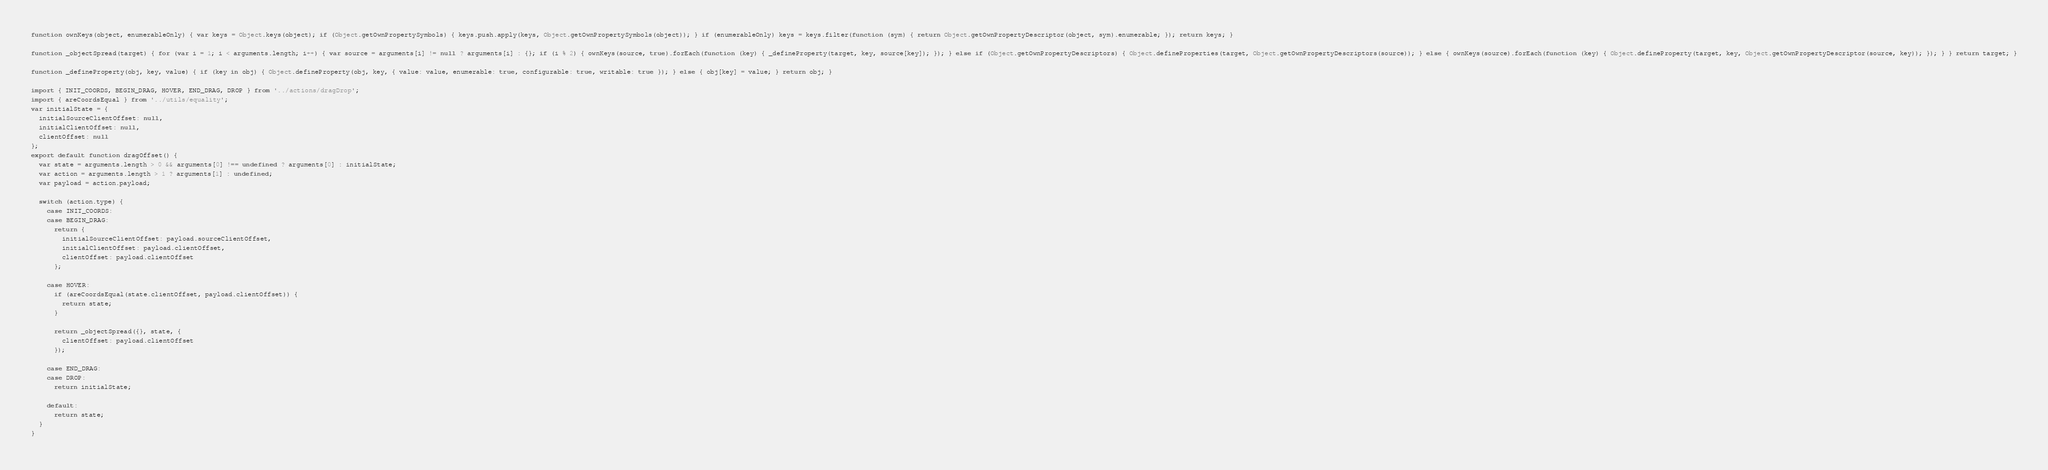<code> <loc_0><loc_0><loc_500><loc_500><_JavaScript_>function ownKeys(object, enumerableOnly) { var keys = Object.keys(object); if (Object.getOwnPropertySymbols) { keys.push.apply(keys, Object.getOwnPropertySymbols(object)); } if (enumerableOnly) keys = keys.filter(function (sym) { return Object.getOwnPropertyDescriptor(object, sym).enumerable; }); return keys; }

function _objectSpread(target) { for (var i = 1; i < arguments.length; i++) { var source = arguments[i] != null ? arguments[i] : {}; if (i % 2) { ownKeys(source, true).forEach(function (key) { _defineProperty(target, key, source[key]); }); } else if (Object.getOwnPropertyDescriptors) { Object.defineProperties(target, Object.getOwnPropertyDescriptors(source)); } else { ownKeys(source).forEach(function (key) { Object.defineProperty(target, key, Object.getOwnPropertyDescriptor(source, key)); }); } } return target; }

function _defineProperty(obj, key, value) { if (key in obj) { Object.defineProperty(obj, key, { value: value, enumerable: true, configurable: true, writable: true }); } else { obj[key] = value; } return obj; }

import { INIT_COORDS, BEGIN_DRAG, HOVER, END_DRAG, DROP } from '../actions/dragDrop';
import { areCoordsEqual } from '../utils/equality';
var initialState = {
  initialSourceClientOffset: null,
  initialClientOffset: null,
  clientOffset: null
};
export default function dragOffset() {
  var state = arguments.length > 0 && arguments[0] !== undefined ? arguments[0] : initialState;
  var action = arguments.length > 1 ? arguments[1] : undefined;
  var payload = action.payload;

  switch (action.type) {
    case INIT_COORDS:
    case BEGIN_DRAG:
      return {
        initialSourceClientOffset: payload.sourceClientOffset,
        initialClientOffset: payload.clientOffset,
        clientOffset: payload.clientOffset
      };

    case HOVER:
      if (areCoordsEqual(state.clientOffset, payload.clientOffset)) {
        return state;
      }

      return _objectSpread({}, state, {
        clientOffset: payload.clientOffset
      });

    case END_DRAG:
    case DROP:
      return initialState;

    default:
      return state;
  }
}</code> 